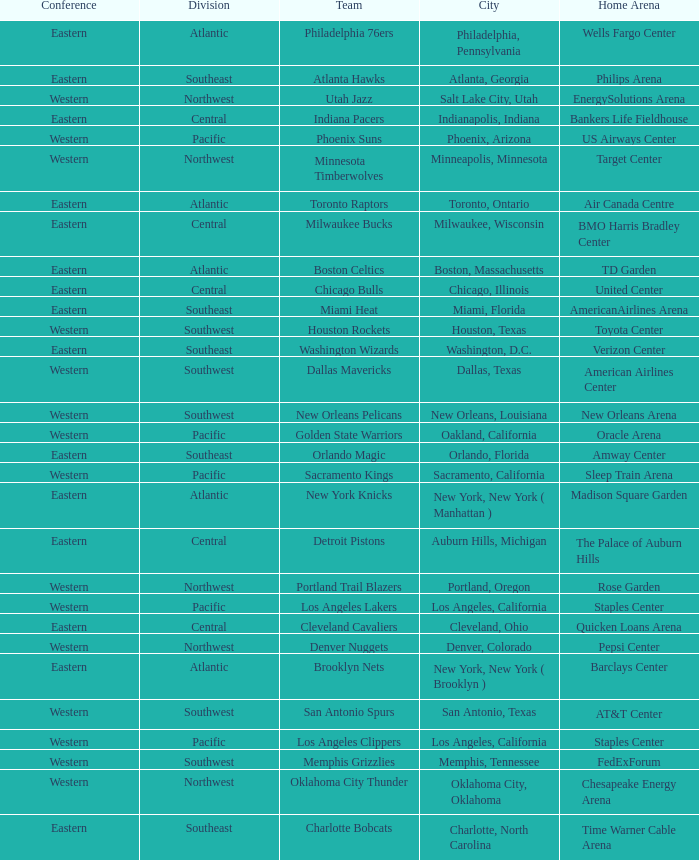Which division do the Toronto Raptors belong in? Atlantic. 